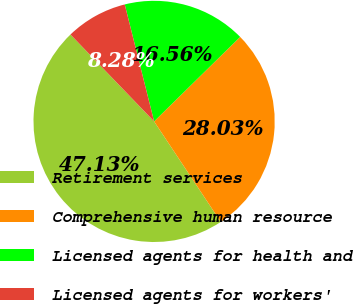Convert chart to OTSL. <chart><loc_0><loc_0><loc_500><loc_500><pie_chart><fcel>Retirement services<fcel>Comprehensive human resource<fcel>Licensed agents for health and<fcel>Licensed agents for workers'<nl><fcel>47.13%<fcel>28.03%<fcel>16.56%<fcel>8.28%<nl></chart> 